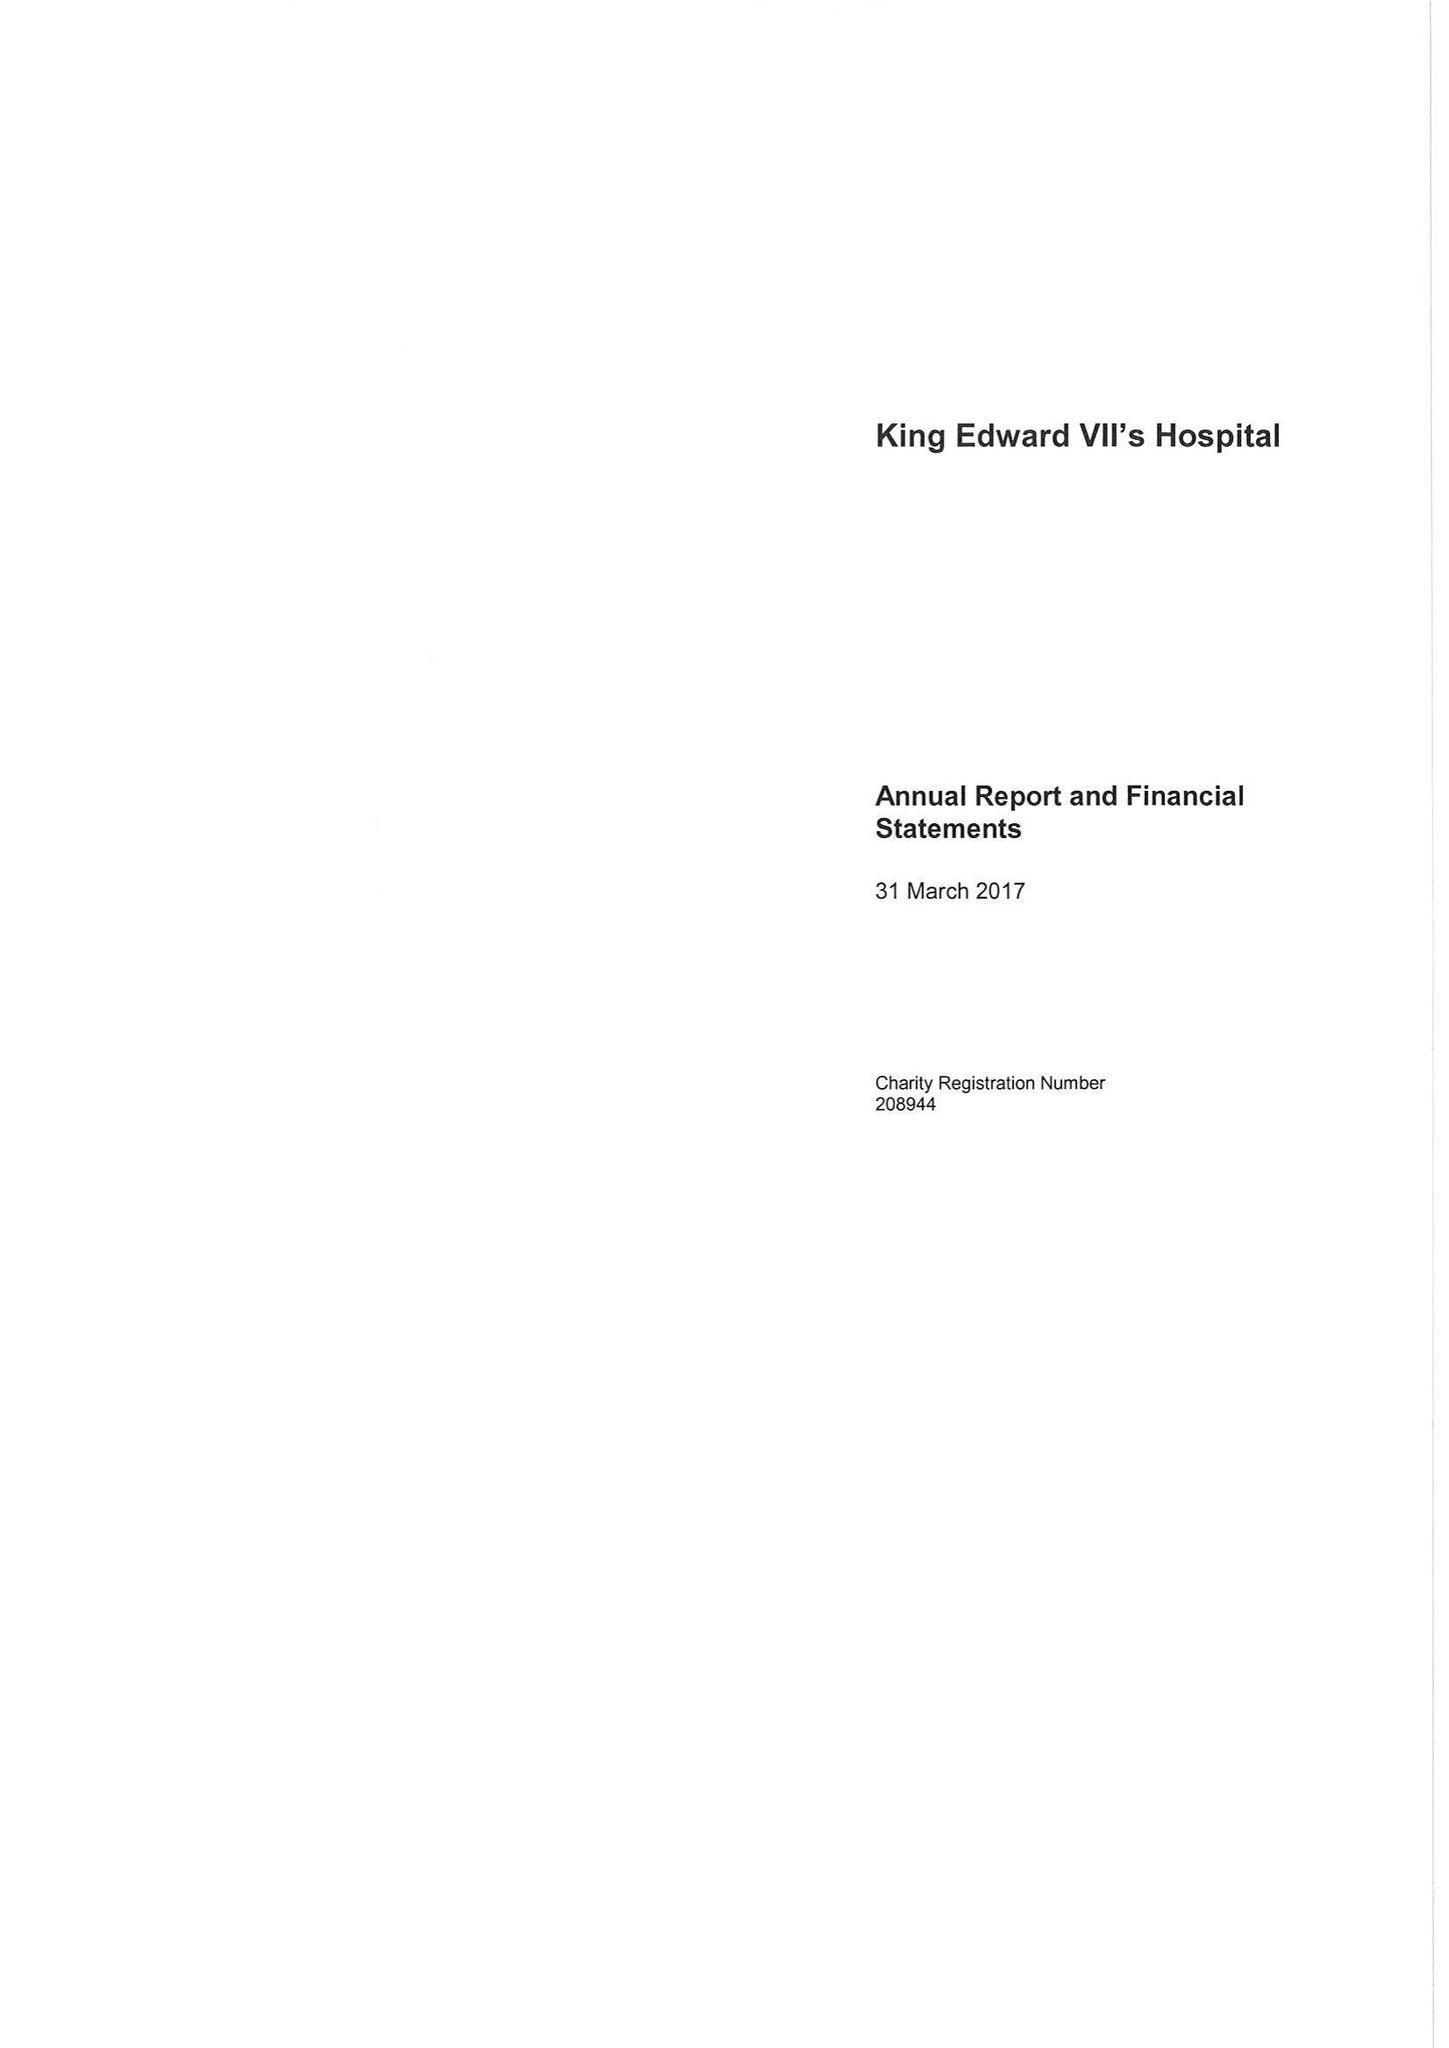What is the value for the charity_name?
Answer the question using a single word or phrase. King Edward Vii's Hospital Sister Agnes 